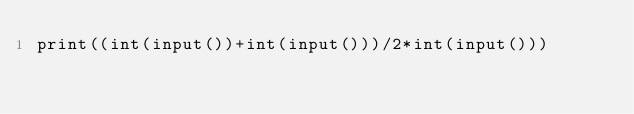Convert code to text. <code><loc_0><loc_0><loc_500><loc_500><_Python_>print((int(input())+int(input()))/2*int(input()))</code> 